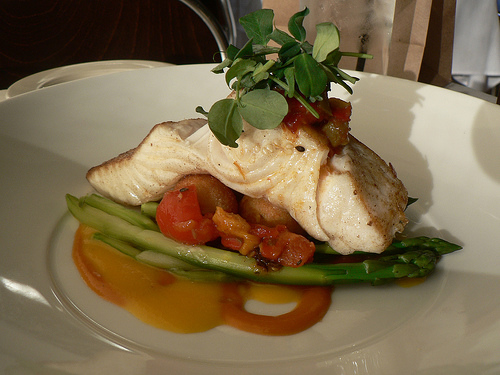<image>
Is the plate to the right of the dish? No. The plate is not to the right of the dish. The horizontal positioning shows a different relationship. 